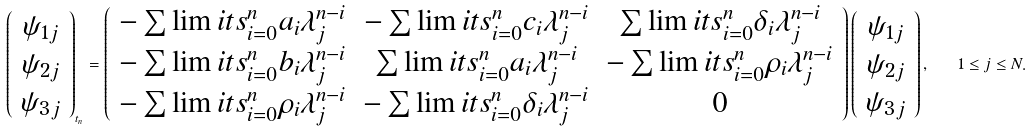Convert formula to latex. <formula><loc_0><loc_0><loc_500><loc_500>\left ( \begin{array} { c } \psi _ { 1 j } \\ \psi _ { 2 j } \\ \psi _ { 3 j } \end{array} \right ) _ { t _ { n } } = \left ( \begin{array} { c c c } - \sum \lim i t s _ { i = 0 } ^ { n } a _ { i } \lambda _ { j } ^ { n - i } & - \sum \lim i t s _ { i = 0 } ^ { n } c _ { i } \lambda _ { j } ^ { n - i } & \sum \lim i t s _ { i = 0 } ^ { n } \delta _ { i } \lambda _ { j } ^ { n - i } \\ - \sum \lim i t s _ { i = 0 } ^ { n } b _ { i } \lambda _ { j } ^ { n - i } & \sum \lim i t s _ { i = 0 } ^ { n } a _ { i } \lambda _ { j } ^ { n - i } & - \sum \lim i t s _ { i = 0 } ^ { n } \rho _ { i } \lambda _ { j } ^ { n - i } \\ - \sum \lim i t s _ { i = 0 } ^ { n } \rho _ { i } \lambda _ { j } ^ { n - i } & - \sum \lim i t s _ { i = 0 } ^ { n } \delta _ { i } \lambda _ { j } ^ { n - i } & 0 \end{array} \right ) \left ( \begin{array} { c } \psi _ { 1 j } \\ \psi _ { 2 j } \\ \psi _ { 3 j } \end{array} \right ) , \quad 1 \leq j \leq N .</formula> 